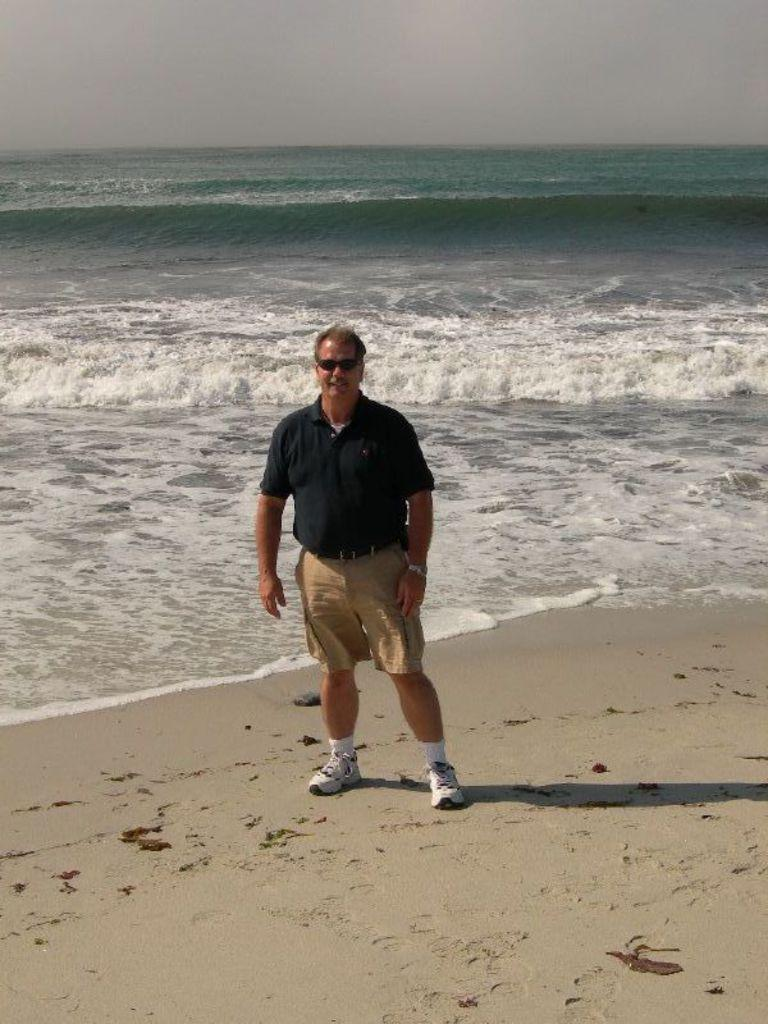What is the man in the image wearing on his upper body? The man is wearing a t-shirt. What type of eyewear is the man wearing in the image? The man is wearing shades. What type of pants is the man wearing in the image? The man is wearing shorts. What type of footwear is the man wearing in the image? The man is wearing white shoes. Can you describe the shadow in the image? There is a shadow in the image, but its specific details are not clear from the provided facts. What can be seen in the background of the image? There is water visible in the background of the image. How many mice are sitting on the man's neck in the image? There are no mice visible in the image. 